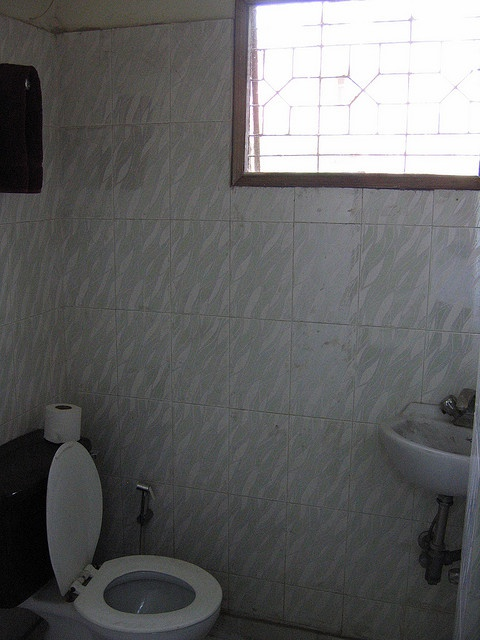Describe the objects in this image and their specific colors. I can see toilet in black, gray, and purple tones and sink in black, gray, and purple tones in this image. 